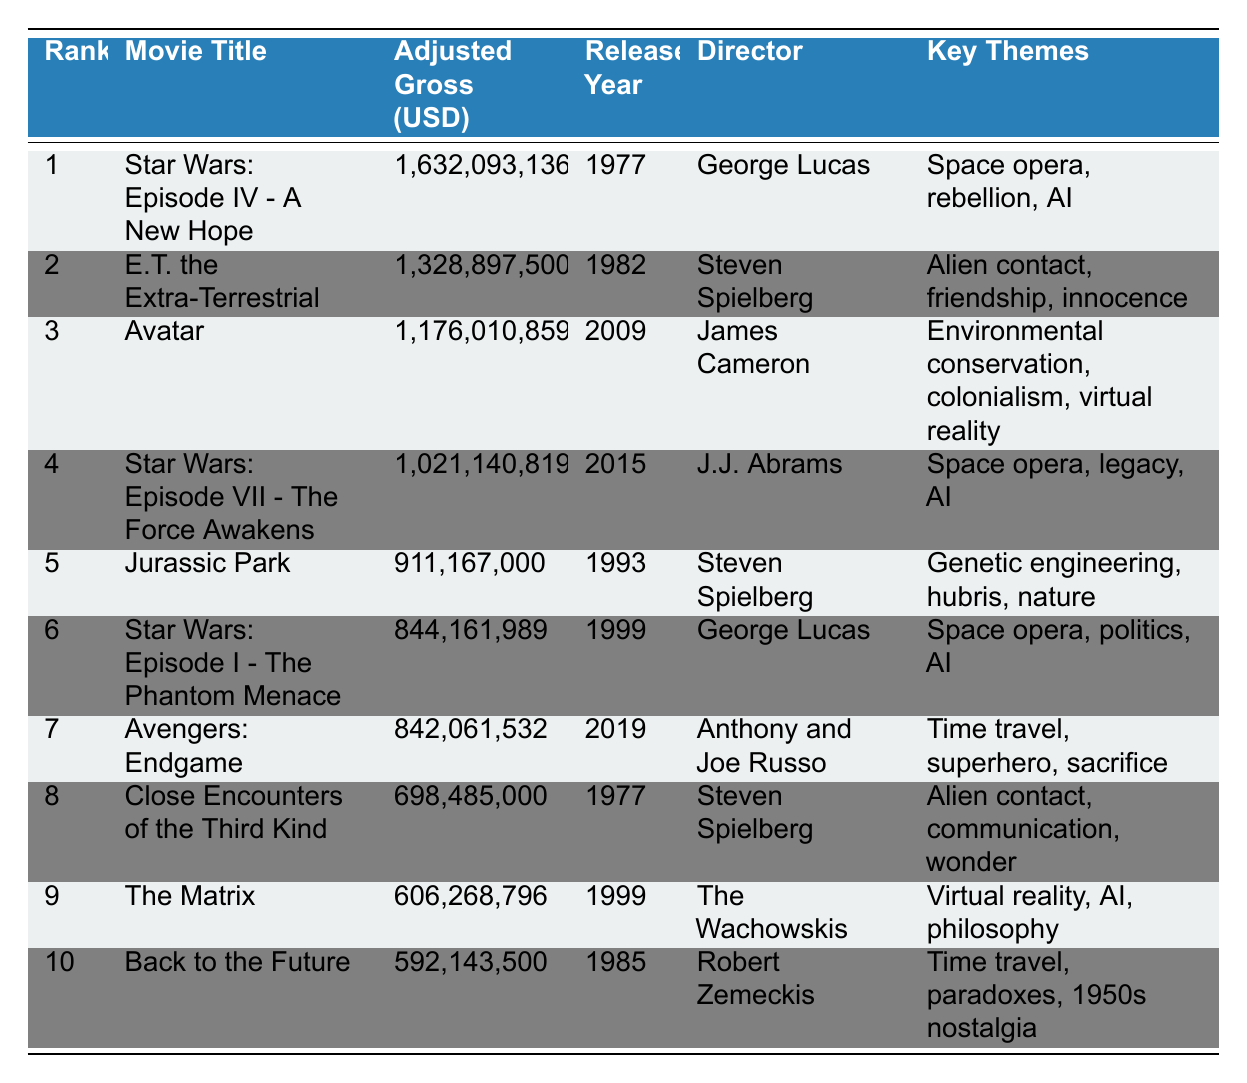What is the highest-grossing science fiction movie adjusted for inflation? The table shows that the highest-grossing movie is "Star Wars: Episode IV - A New Hope" with an adjusted gross of 1,632,093,136 USD.
Answer: Star Wars: Episode IV - A New Hope Who directed "E.T. the Extra-Terrestrial"? Looking at the table, it shows that "E.T. the Extra-Terrestrial" was directed by Steven Spielberg.
Answer: Steven Spielberg How much did "Avatar" earn adjusted for inflation? According to the table, "Avatar" earned an adjusted gross of 1,176,010,859 USD.
Answer: 1,176,010,859 USD Which movie released in 1999 has the lowest adjusted gross? The table indicates that "Star Wars: Episode I - The Phantom Menace" has the lowest adjusted gross of 844,161,989 USD among 1999 releases.
Answer: Star Wars: Episode I - The Phantom Menace Is "The Matrix" listed as having a higher adjusted gross than "Back to the Future"? The adjusted gross for "The Matrix" is 606,268,796 USD, which is lower than "Back to the Future" at 592,143,500 USD, therefore, the statement is false.
Answer: No What are the key themes of "Avengers: Endgame"? The table shows that the key themes of "Avengers: Endgame" are time travel, superhero, and sacrifice.
Answer: Time travel, superhero, sacrifice If we sum the adjusted gross of the top three movies, what do we get? Adding the adjusted gross of "Star Wars: Episode IV - A New Hope" (1,632,093,136), "E.T. the Extra-Terrestrial" (1,328,897,500), and "Avatar" (1,176,010,859) results in 4,137,091,495 USD.
Answer: 4,137,091,495 USD Which movie has the earliest release date and what are its key themes? The earliest release date in the table is 1977 for both "Star Wars: Episode IV - A New Hope" and "Close Encounters of the Third Kind." The key themes for "Star Wars: Episode IV - A New Hope" are space opera, rebellion, and AI, while "Close Encounters of the Third Kind" features alien contact, communication, and wonder.
Answer: Star Wars: Episode IV - A New Hope: Space opera, rebellion, AI; Close Encounters of the Third Kind: Alien contact, communication, wonder What is the average adjusted gross of the top 5 movies? The total adjusted gross for the top 5 movies (1,632,093,136 + 1,328,897,500 + 1,176,010,859 + 1,021,140,819 + 911,167,000) is 5,069,509,314. Dividing this sum by 5 gives an average of 1,013,901,862.8 USD.
Answer: 1,013,901,862.8 USD Are there more movies directed by Steven Spielberg in the top 10 than by George Lucas? The table shows that Steven Spielberg directed 3 movies ("E.T. the Extra-Terrestrial," "Jurassic Park," and "Close Encounters of the Third Kind") while George Lucas directed 2 movies ("Star Wars: Episode IV - A New Hope" and "Star Wars: Episode I - The Phantom Menace"). Therefore, the statement is true.
Answer: Yes 